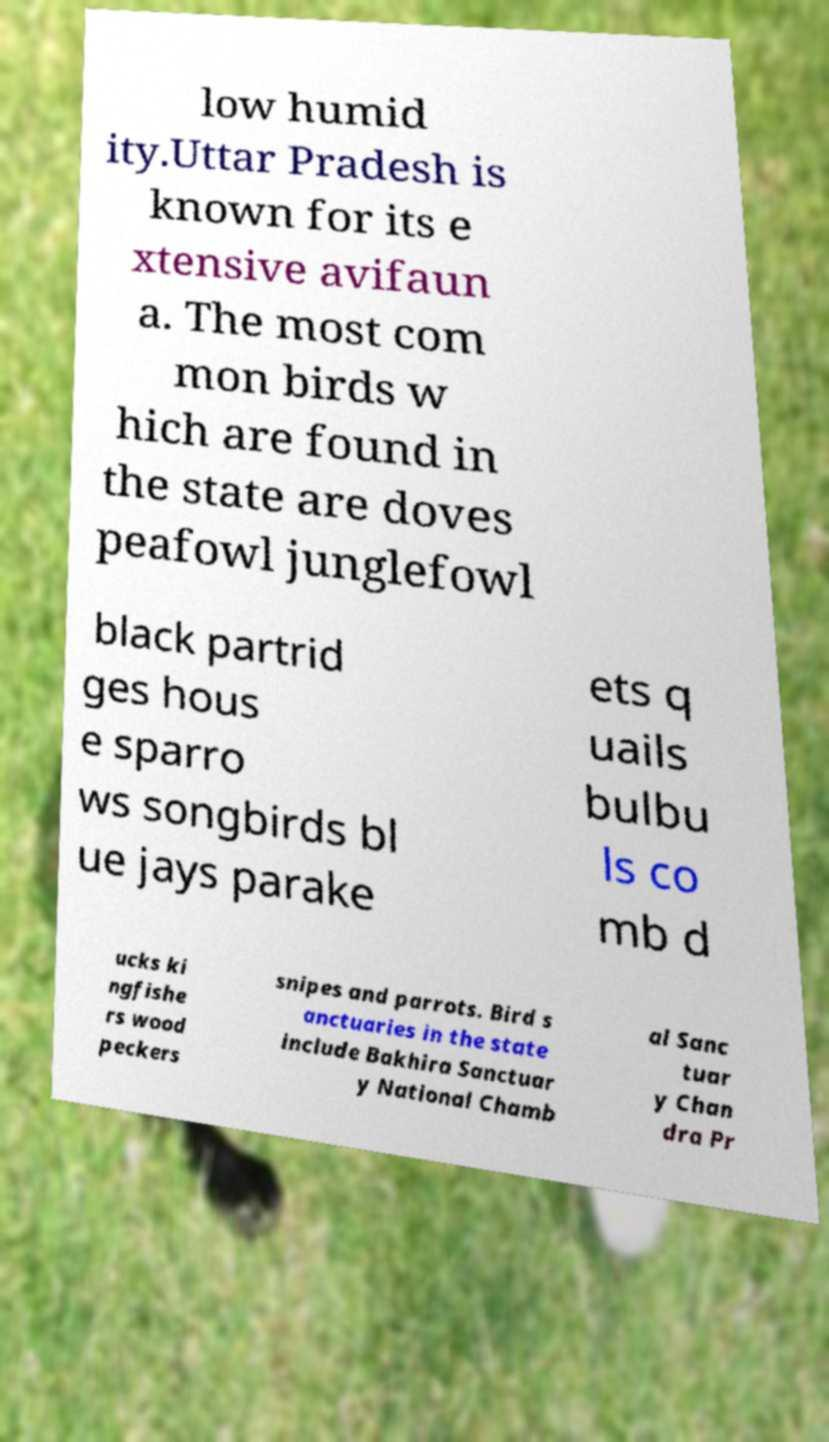Can you read and provide the text displayed in the image?This photo seems to have some interesting text. Can you extract and type it out for me? low humid ity.Uttar Pradesh is known for its e xtensive avifaun a. The most com mon birds w hich are found in the state are doves peafowl junglefowl black partrid ges hous e sparro ws songbirds bl ue jays parake ets q uails bulbu ls co mb d ucks ki ngfishe rs wood peckers snipes and parrots. Bird s anctuaries in the state include Bakhira Sanctuar y National Chamb al Sanc tuar y Chan dra Pr 